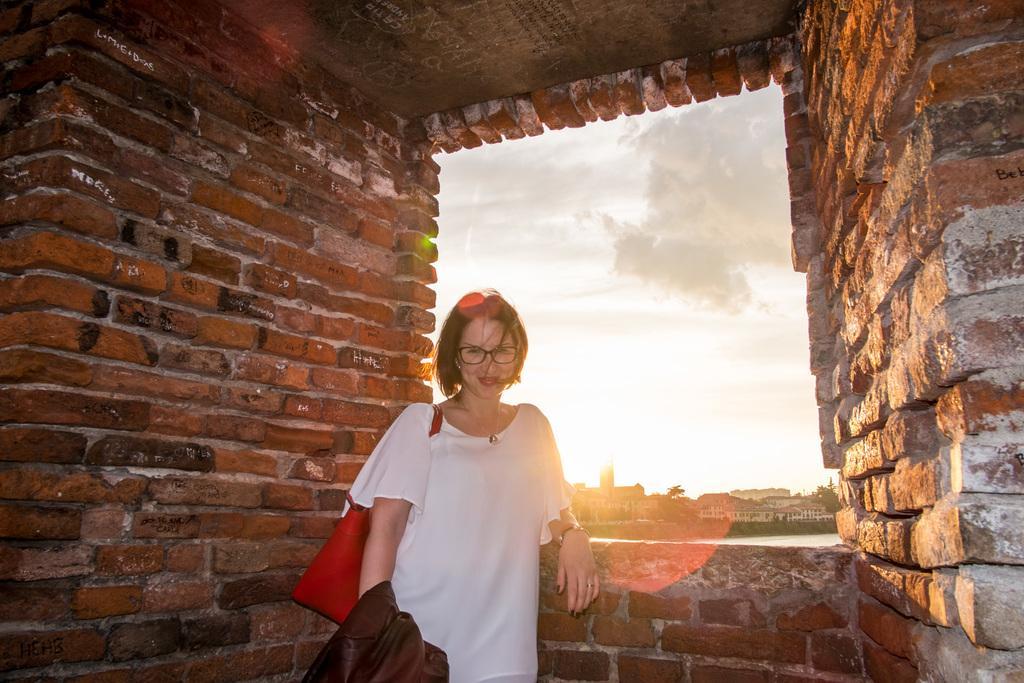Describe this image in one or two sentences. In this picture there is a woman with white dress is standing and smiling. In the foreground it looks like a house. At the back there are buildings and trees. At the top there is sky and there are clouds. At the bottom there is water. 